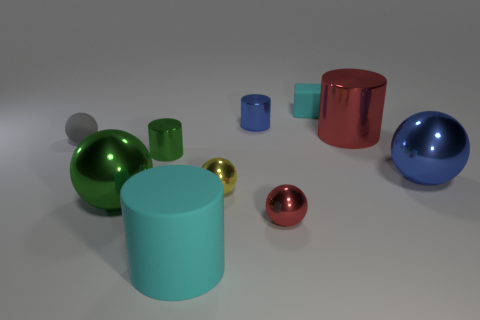How do the textures of the objects compare in the image? The objects display a variety of textures. The large cylinders have a smooth, matte finish, indicative of a rubber-like material. In contrast, the small spheres and the cube boast a polished, reflective surface that suggests a metallic composition, causing them to gleam and stand out against the matte background. 